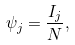<formula> <loc_0><loc_0><loc_500><loc_500>\psi _ { j } = \frac { I _ { j } } { N } ,</formula> 